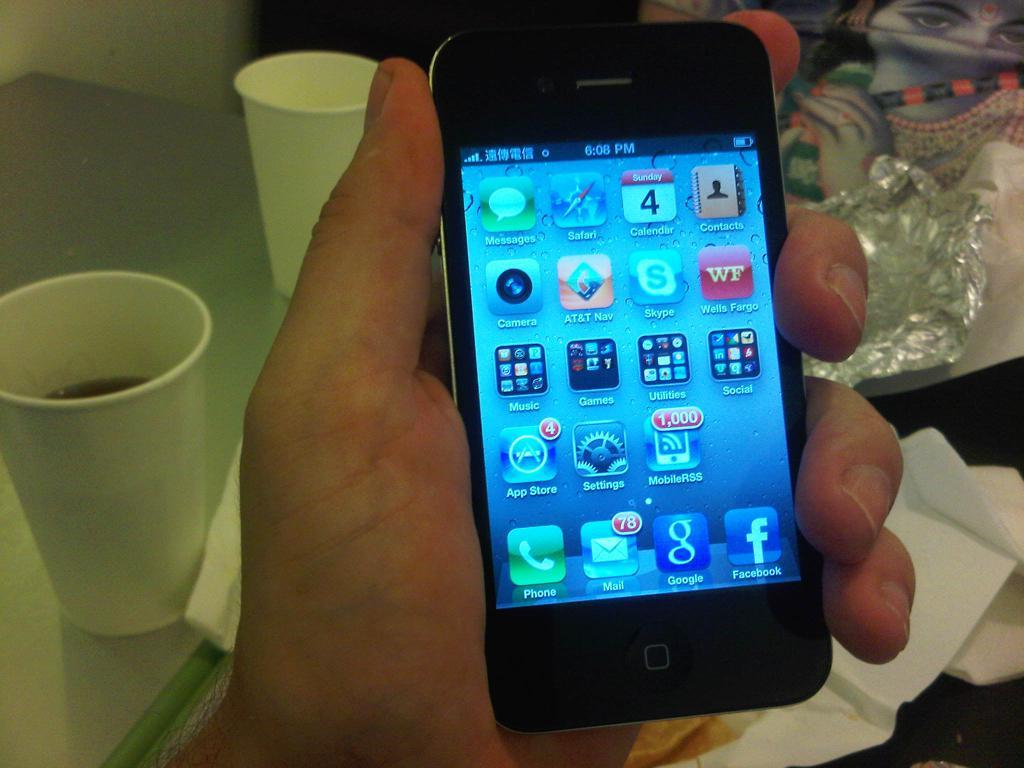<image>
Describe the image concisely. an app that has the word MobileRSS on it 